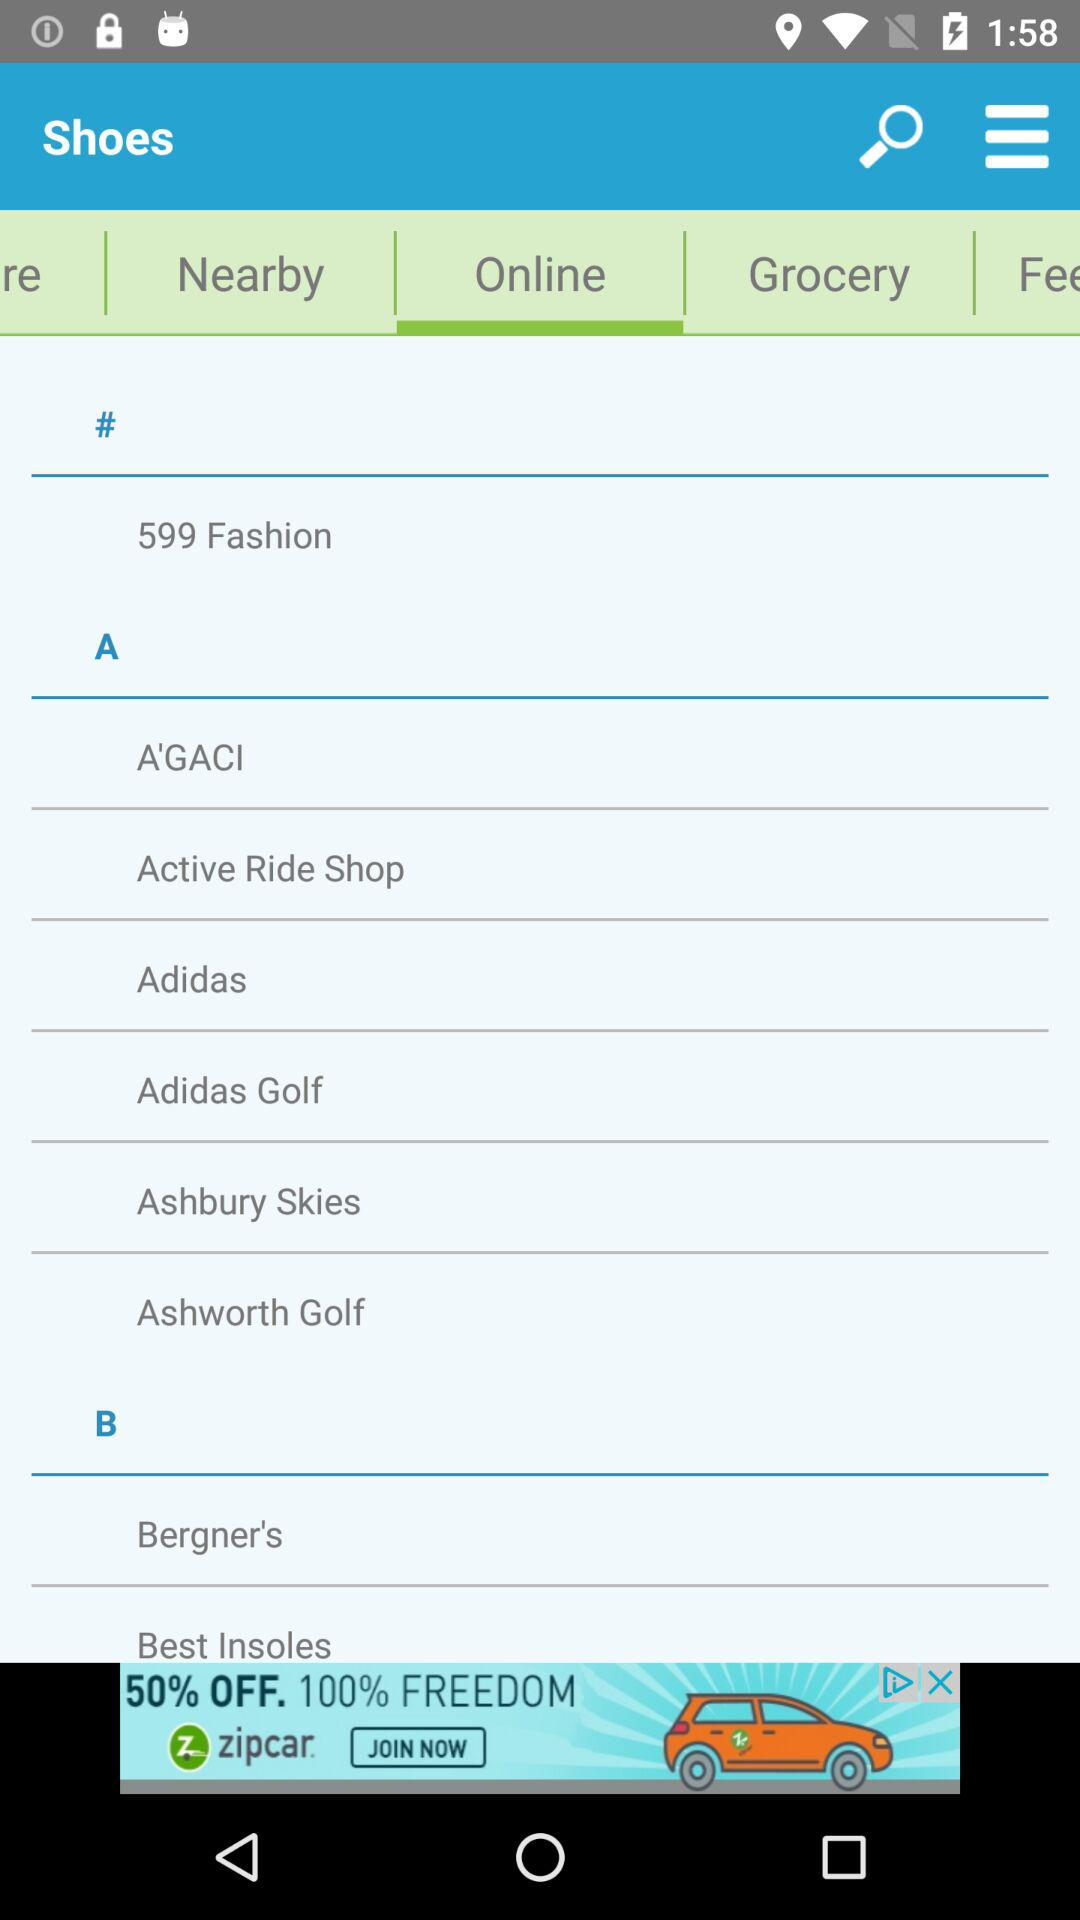What is the mentioned number of fashion items? The mentioned number of fashion items is 599. 